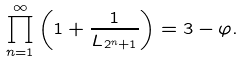Convert formula to latex. <formula><loc_0><loc_0><loc_500><loc_500>\prod _ { n = 1 } ^ { \infty } \left ( 1 + \frac { 1 } { L _ { 2 ^ { n } + 1 } } \right ) = 3 - \varphi .</formula> 